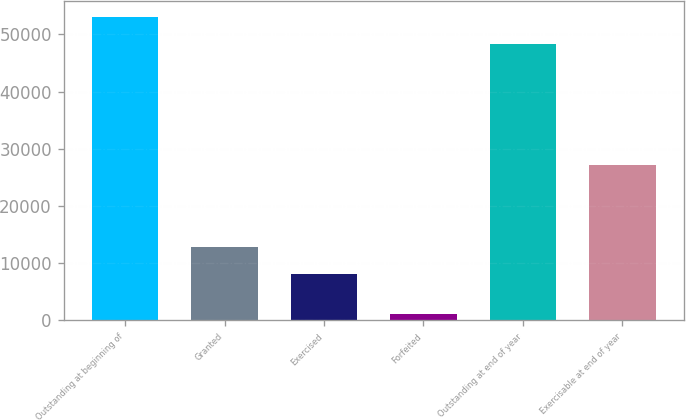<chart> <loc_0><loc_0><loc_500><loc_500><bar_chart><fcel>Outstanding at beginning of<fcel>Granted<fcel>Exercised<fcel>Forfeited<fcel>Outstanding at end of year<fcel>Exercisable at end of year<nl><fcel>53108.7<fcel>12879.7<fcel>8108<fcel>1055<fcel>48337<fcel>27126<nl></chart> 